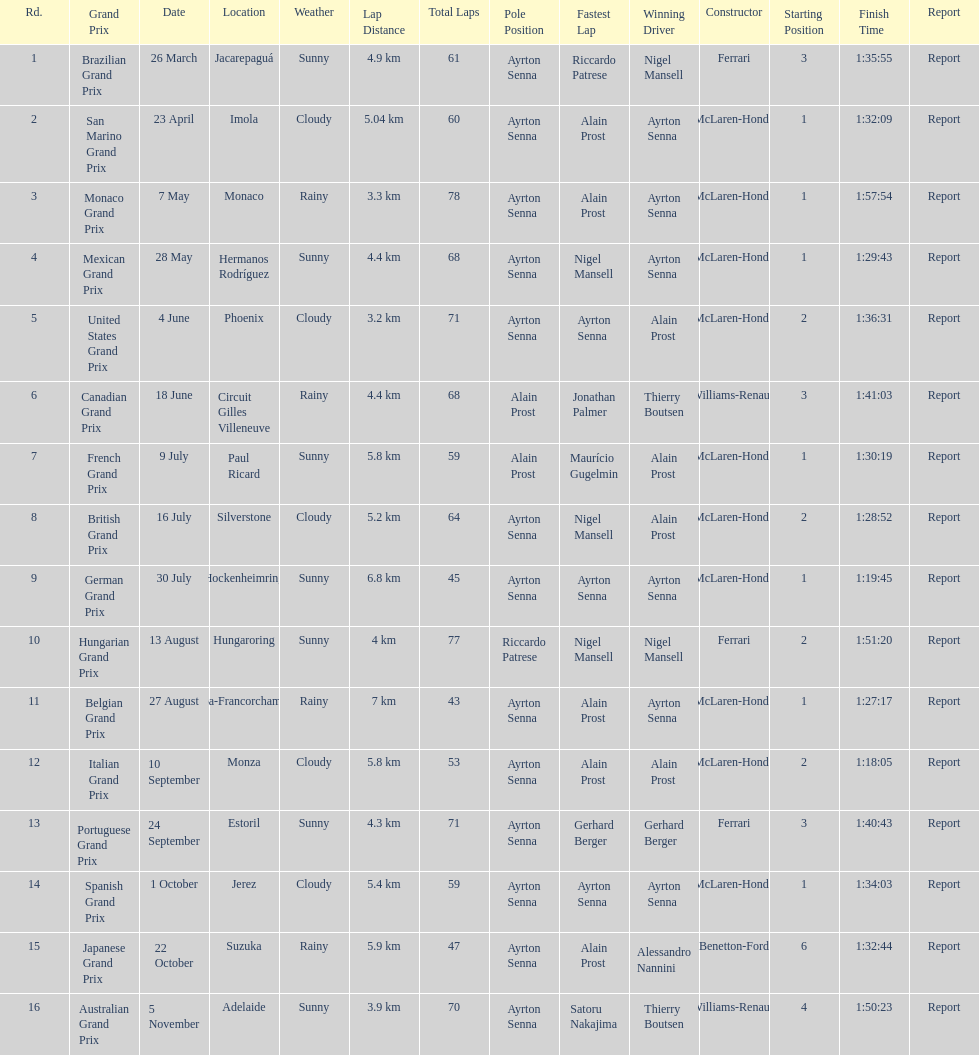How many times was ayrton senna in pole position? 13. 